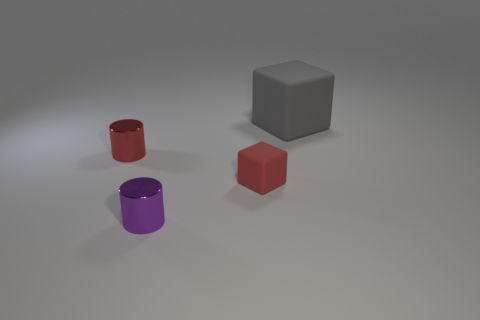Add 1 gray matte blocks. How many objects exist? 5 Subtract all purple cylinders. How many cylinders are left? 1 Subtract 0 blue balls. How many objects are left? 4 Subtract 1 cylinders. How many cylinders are left? 1 Subtract all cyan cylinders. Subtract all yellow cubes. How many cylinders are left? 2 Subtract all yellow balls. How many brown blocks are left? 0 Subtract all small purple rubber objects. Subtract all small things. How many objects are left? 1 Add 4 cubes. How many cubes are left? 6 Add 3 red things. How many red things exist? 5 